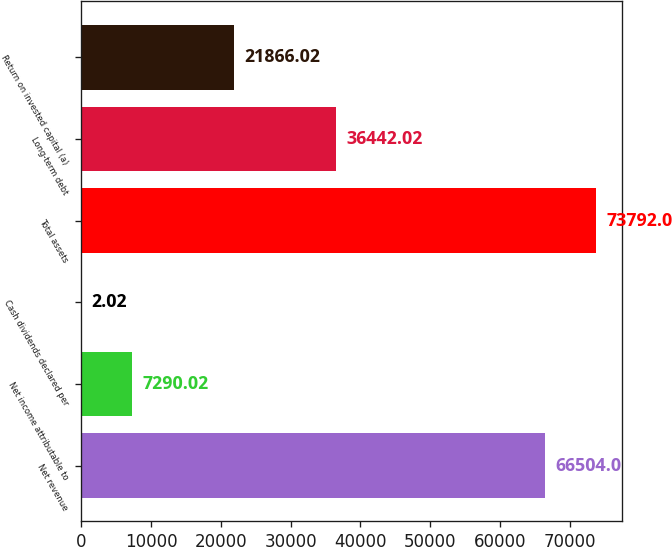<chart> <loc_0><loc_0><loc_500><loc_500><bar_chart><fcel>Net revenue<fcel>Net income attributable to<fcel>Cash dividends declared per<fcel>Total assets<fcel>Long-term debt<fcel>Return on invested capital (a)<nl><fcel>66504<fcel>7290.02<fcel>2.02<fcel>73792<fcel>36442<fcel>21866<nl></chart> 